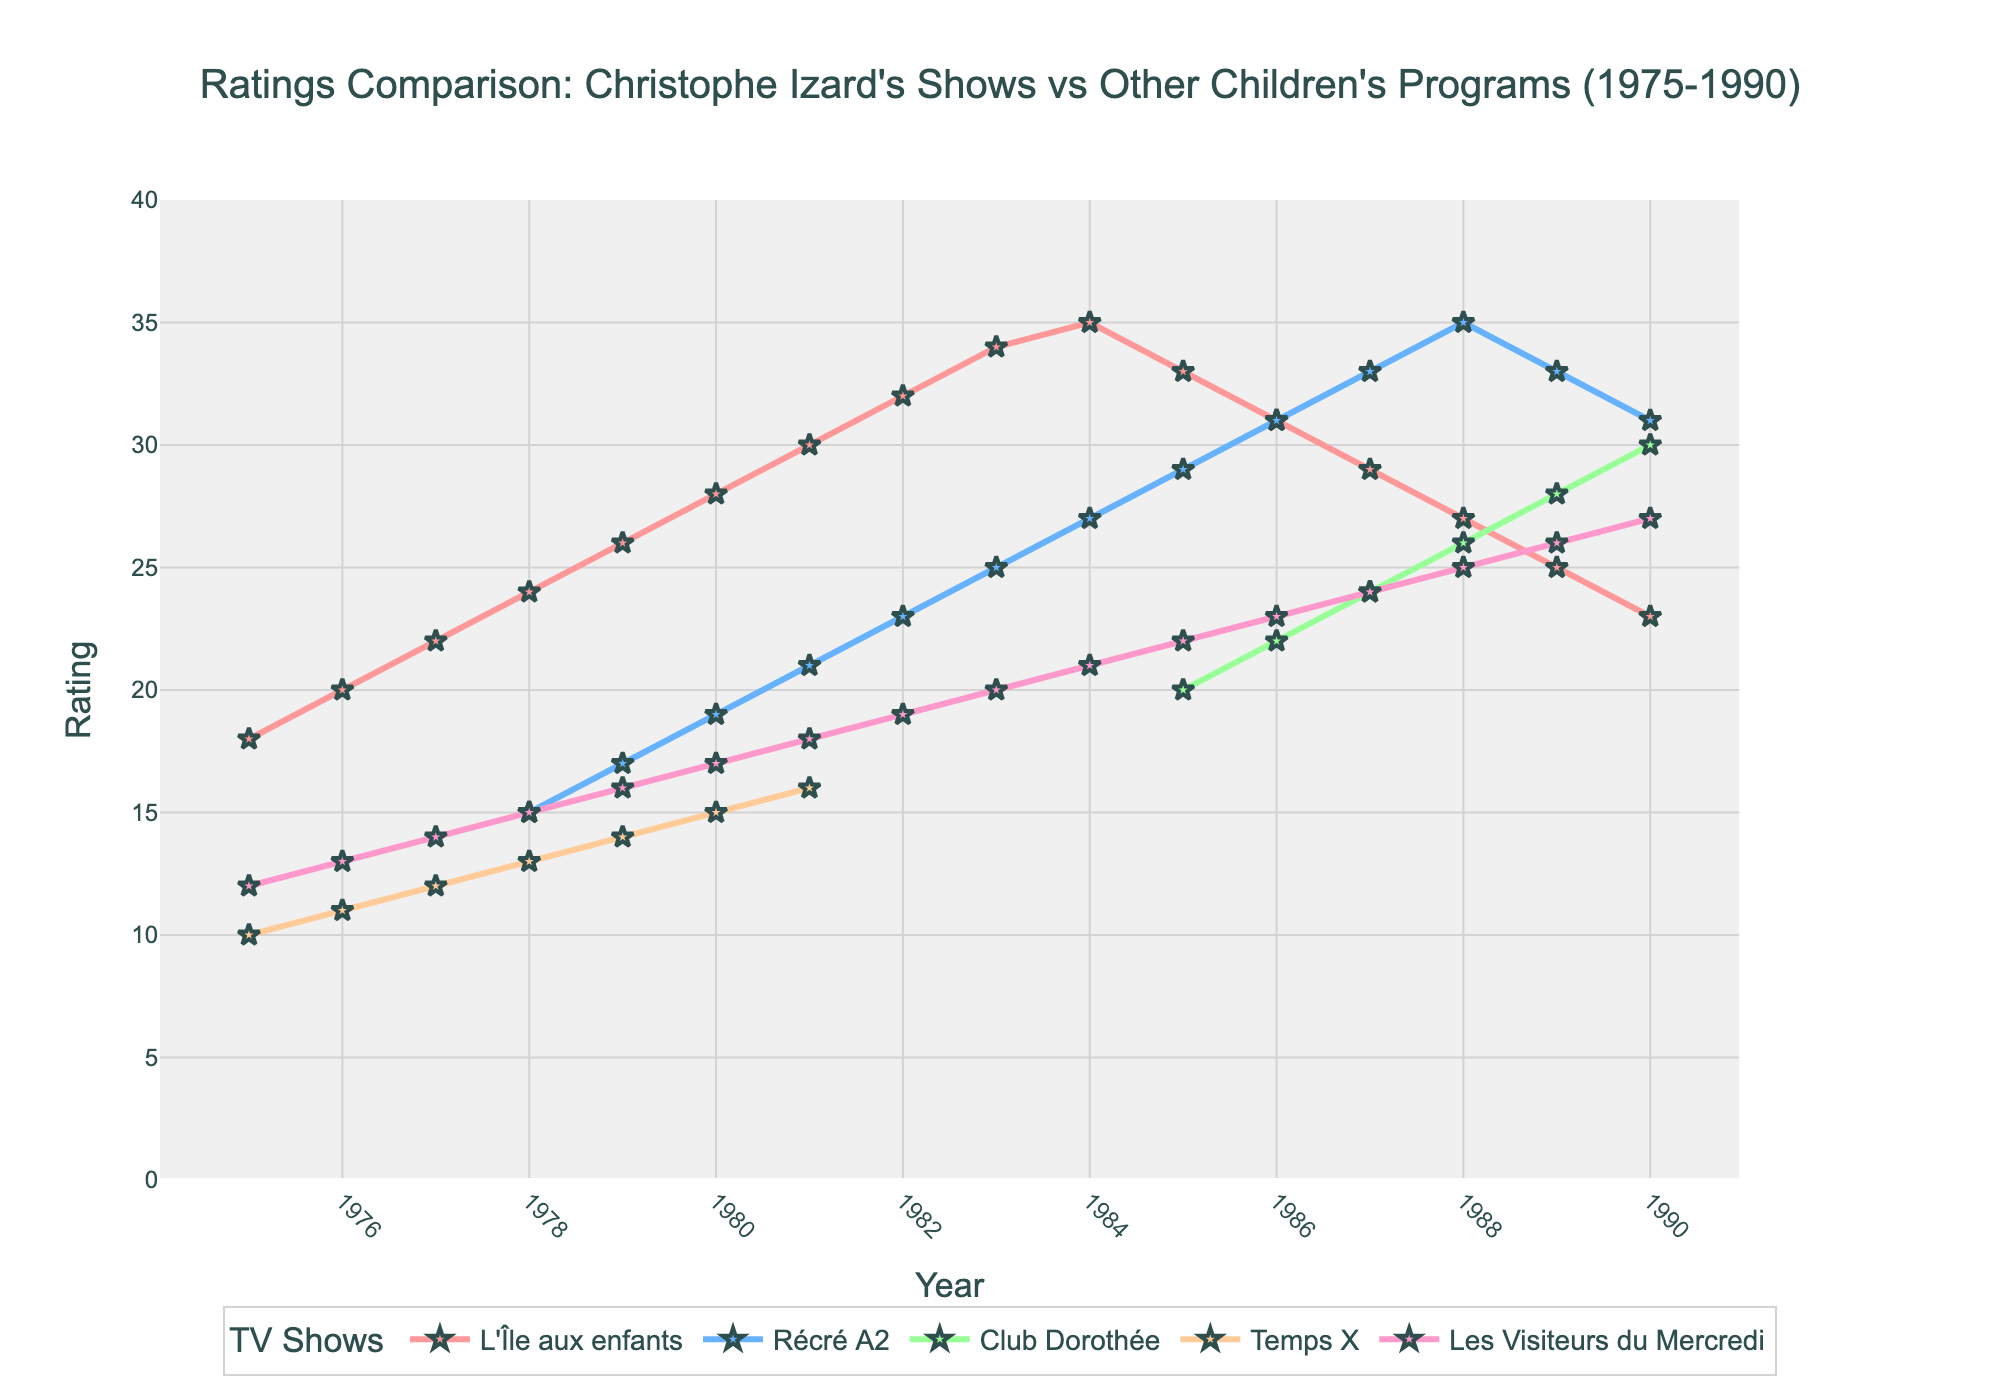Which show had the highest rating in 1984? Refer to the chart and locate the year 1984. Observe the ratings of all shows for this year. The highest point corresponds to "L'Île aux enfants" with a rating of 35.
Answer: L'Île aux enfants Among "L'Île aux enfants" and "Récré A2", which show experienced a higher increase in ratings between 1978 and 1982? Determine the ratings for both shows in 1978 and 1982. "L'Île aux enfants" increased from 24 to 32 (an increase of 8), while "Récré A2" increased from 15 to 23 (an increase of 8). Both shows experienced the same increase of 8.
Answer: Both shows experienced the same increase What was the average rating of "Club Dorothée" during its available data years? Summarize the ratings of "Club Dorothée" from 1985 to 1990: (20 + 22 + 24 + 26 + 28 + 30) = 150. There are 6 data points, so the average is 150 / 6 = 25.
Answer: 25 Which show had the steepest decline in ratings between its peak and the year 1990? Identify the peak ratings of each show and their ratings in 1990. "L'Île aux enfants" declined from a peak of 35 in 1984 to 23 in 1990 (a decline of 12). No other show showed a steeper decline.
Answer: L'Île aux enfants In what year did "Temps X" have its highest rating, and what was that rating? "Temps X" only has ratings for the year 1975 where it reached its highest rating of 10.
Answer: 1975, 10 What's the difference in ratings between "Les Visiteurs du Mercredi" and "Récré A2" in 1978? In 1978, "Récré A2" had a rating of 15, and "Les Visiteurs du Mercredi" had a rating of 15. The difference is 15 - 15 = 0.
Answer: 0 Which show maintained a steady increase in ratings from 1975 to 1983 without any declines? Look at the trends for each show from 1975 to 1983. "L'Île aux enfants" consistently increased its ratings every year within this period.
Answer: L'Île aux enfants How many years did "Récré A2" have higher ratings than "L'Île aux enfants"? Compare the ratings for "Récré A2" and "L'Île aux enfants" in each available year. "Récré A2" never had higher ratings within its dataset range compared to "L'Île aux enfants".
Answer: 0 years 